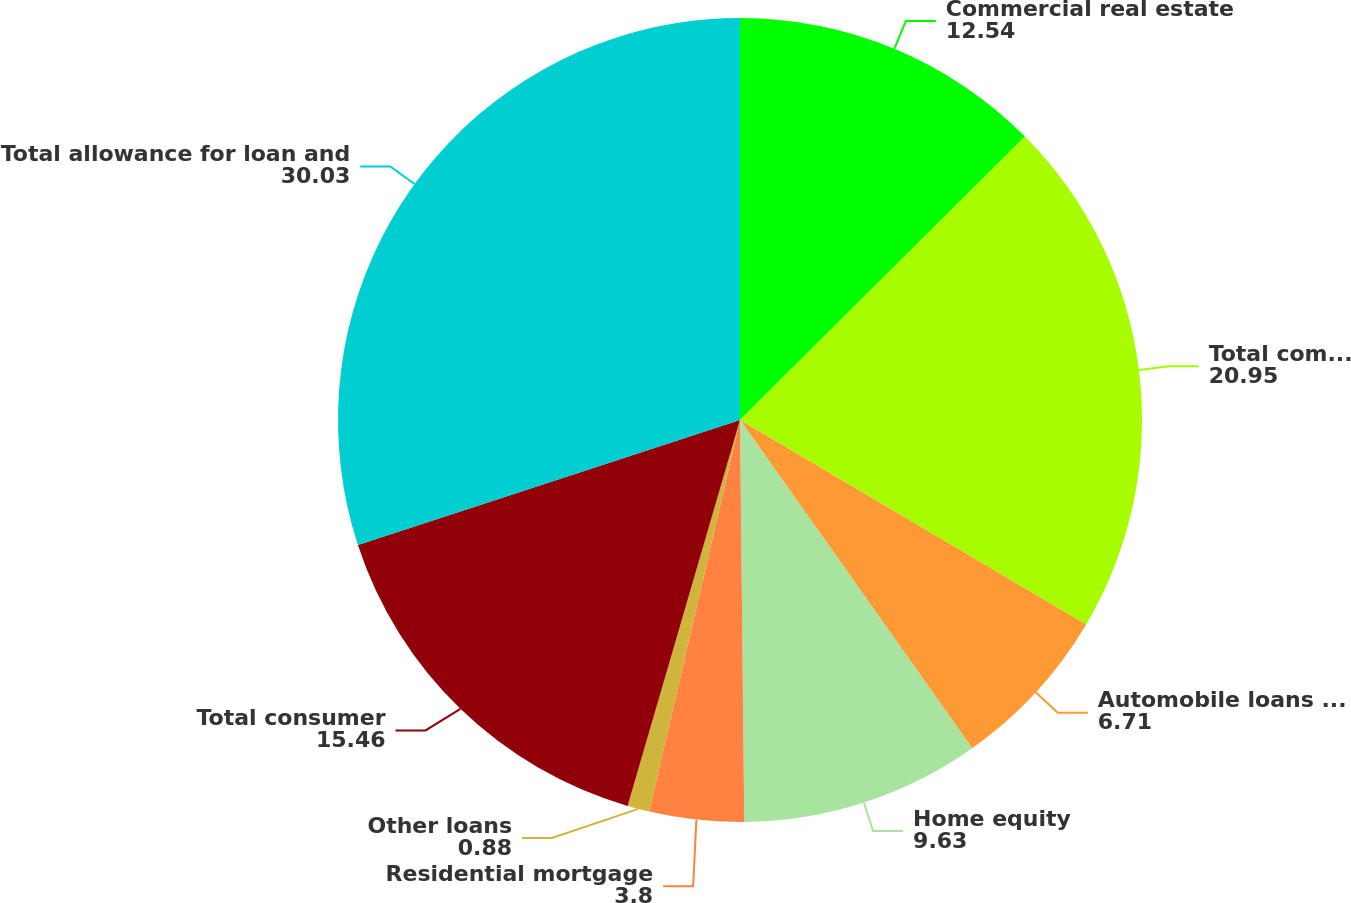Convert chart to OTSL. <chart><loc_0><loc_0><loc_500><loc_500><pie_chart><fcel>Commercial real estate<fcel>Total commercial<fcel>Automobile loans and leases<fcel>Home equity<fcel>Residential mortgage<fcel>Other loans<fcel>Total consumer<fcel>Total allowance for loan and<nl><fcel>12.54%<fcel>20.95%<fcel>6.71%<fcel>9.63%<fcel>3.8%<fcel>0.88%<fcel>15.46%<fcel>30.03%<nl></chart> 